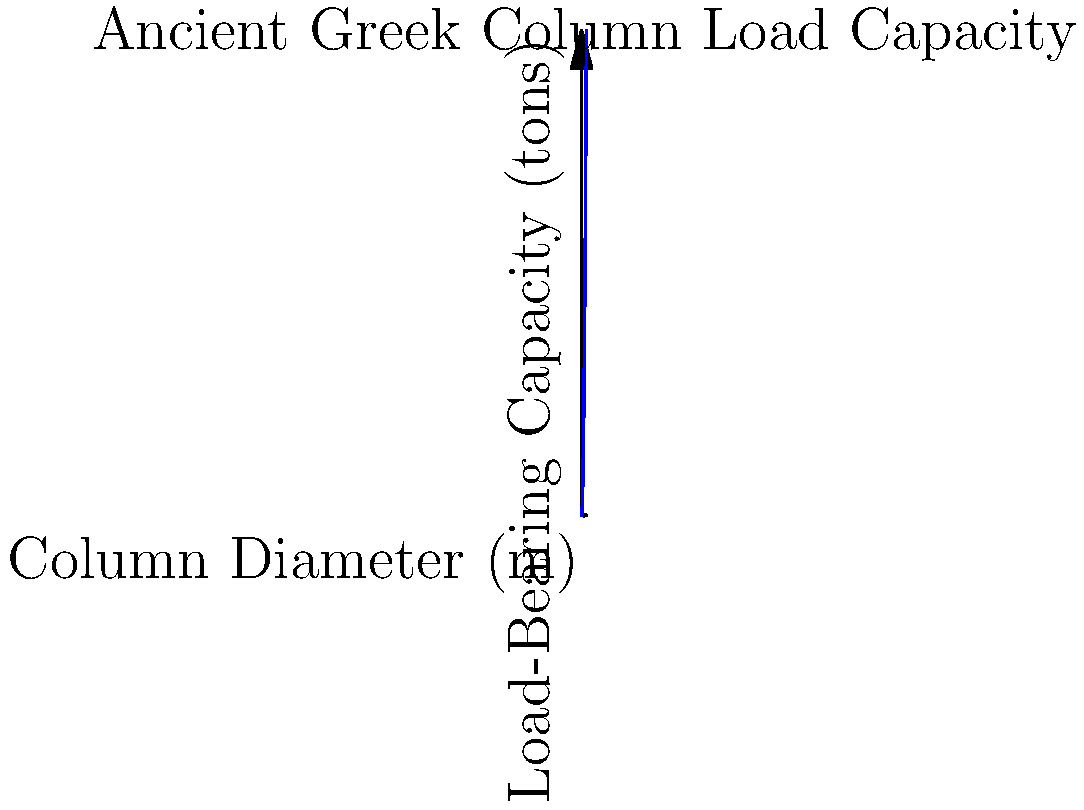Based on the graph showing the relationship between column diameter and load-bearing capacity for ancient Greek columns, estimate the load-bearing capacity of a column with a diameter of 1.5 meters. How does this compare to the load-bearing capacity of columns in Komotini's historical buildings? To solve this problem, let's follow these steps:

1. Understand the graph:
   The x-axis represents the column diameter in meters, and the y-axis represents the load-bearing capacity in tons.

2. Identify the relationship:
   The curve appears to be quadratic, suggesting that the load-bearing capacity is proportional to the square of the diameter.

3. Estimate the load-bearing capacity for a 1.5m diameter column:
   - Locate 1.5m on the x-axis
   - Move up to the curve
   - Read the corresponding value on the y-axis

4. Calculate the exact value:
   If we assume the relationship is exactly $y = 50x^2$, where $y$ is the load-bearing capacity in tons and $x$ is the diameter in meters, then:

   $y = 50 * (1.5)^2 = 50 * 2.25 = 112.5$ tons

5. Compare to Komotini's historical buildings:
   While we don't have specific data for Komotini's buildings, we can make an educated guess that most historical buildings in the area would have columns with smaller diameters, likely ranging from 0.5m to 1m. This would result in significantly lower load-bearing capacities, probably between 12.5 tons (for 0.5m) and 50 tons (for 1m).
Answer: 112.5 tons; likely 2-4 times higher than typical historical columns in Komotini 